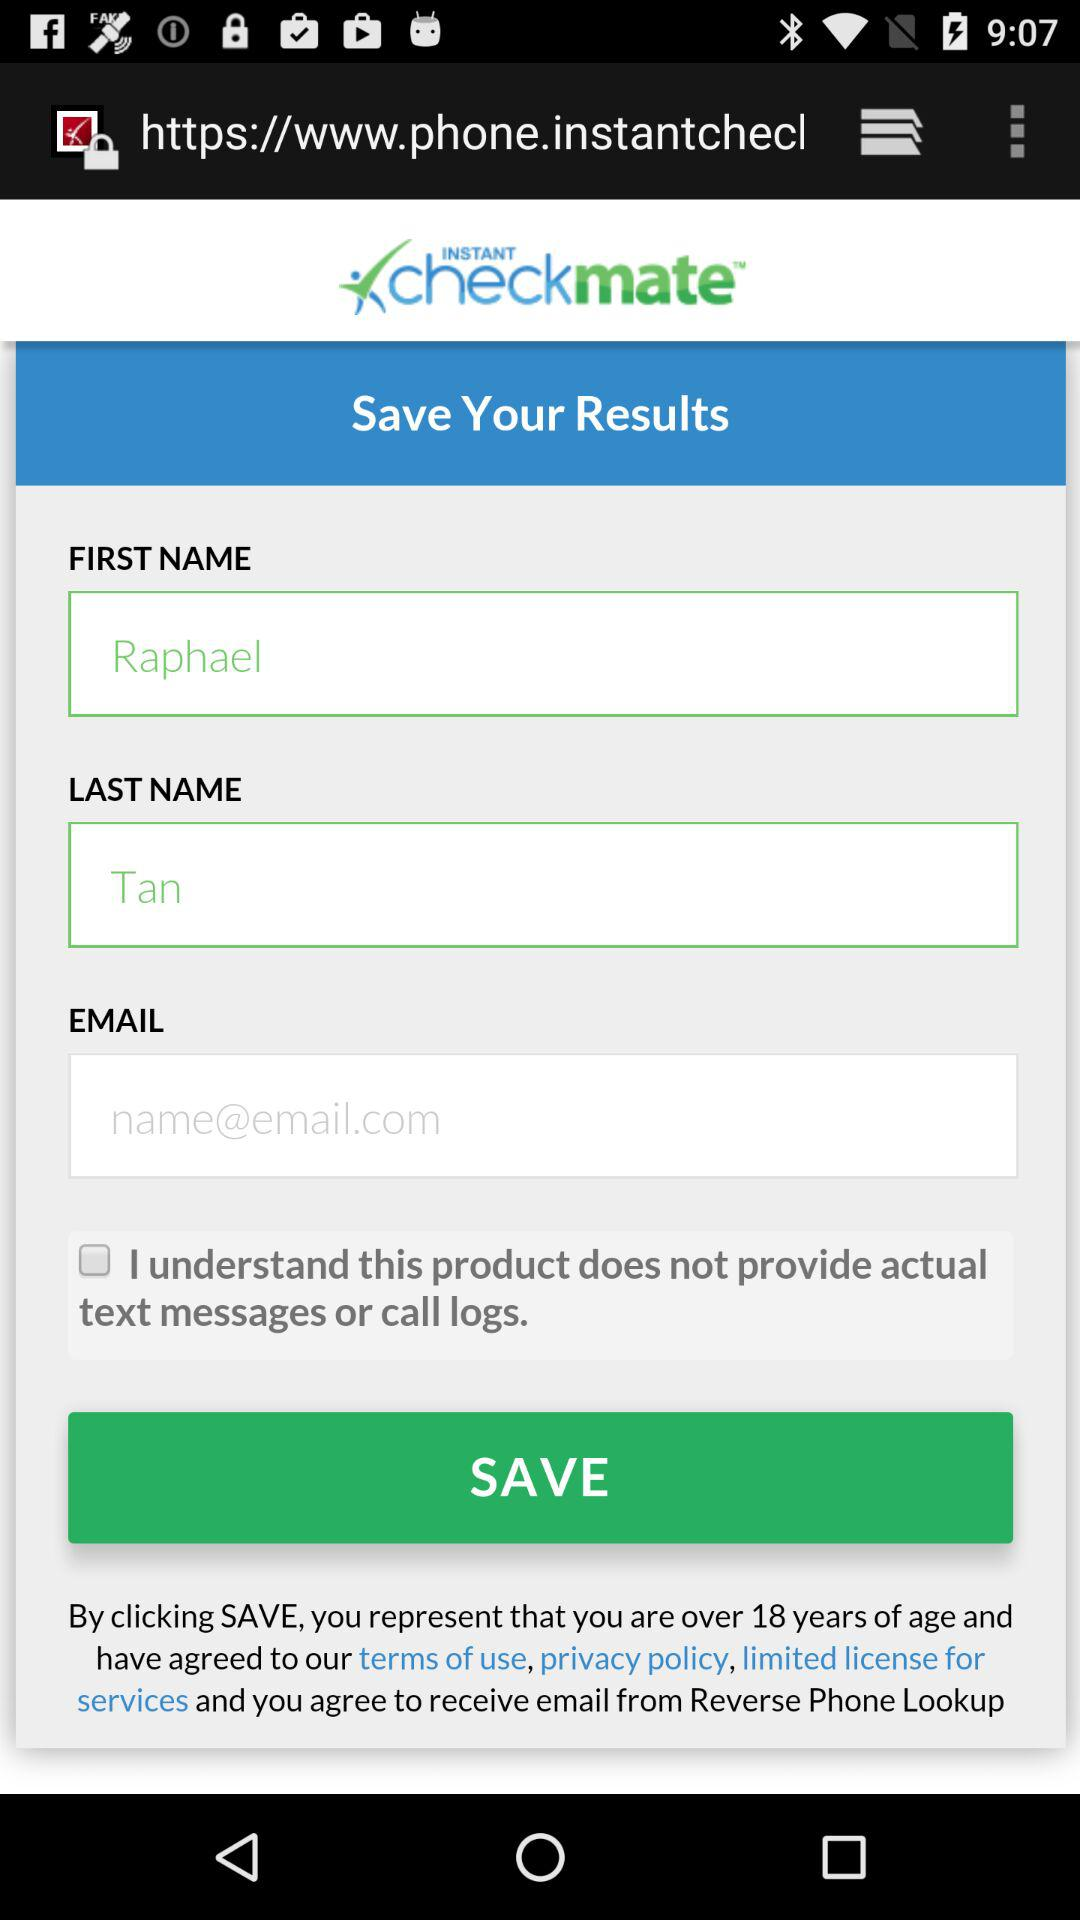What is the last name? The last name is Tan. 